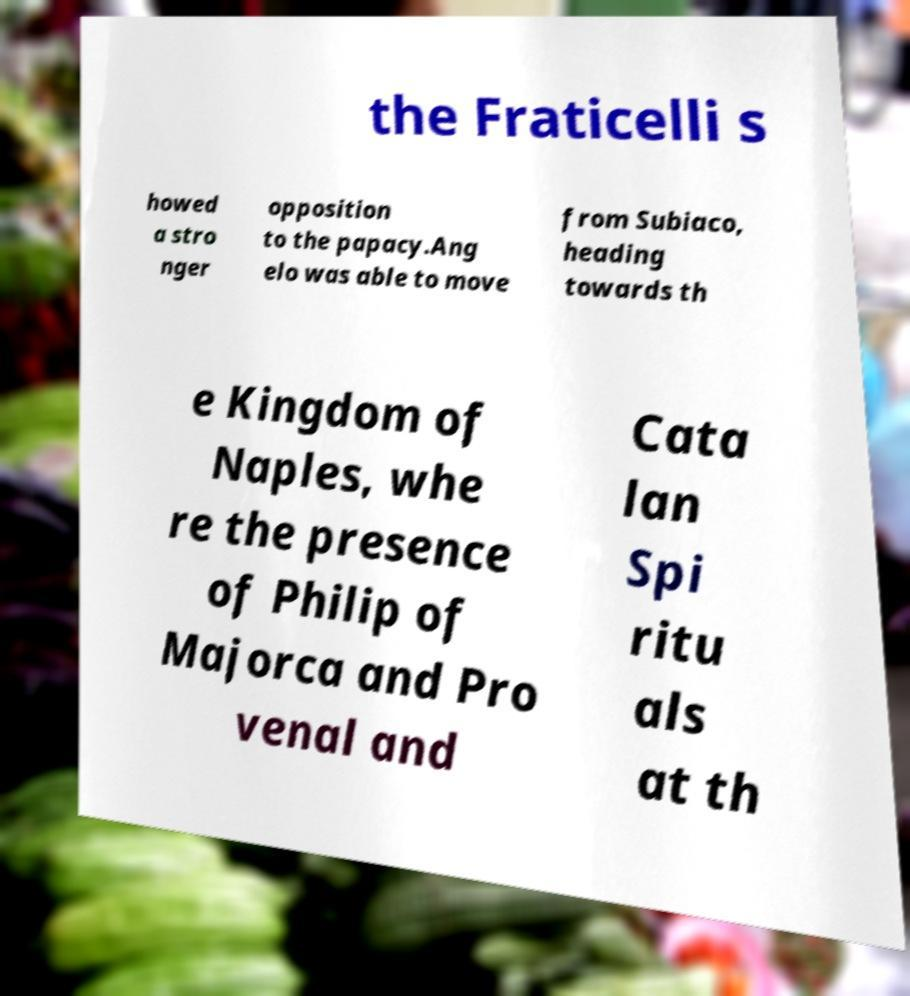There's text embedded in this image that I need extracted. Can you transcribe it verbatim? the Fraticelli s howed a stro nger opposition to the papacy.Ang elo was able to move from Subiaco, heading towards th e Kingdom of Naples, whe re the presence of Philip of Majorca and Pro venal and Cata lan Spi ritu als at th 